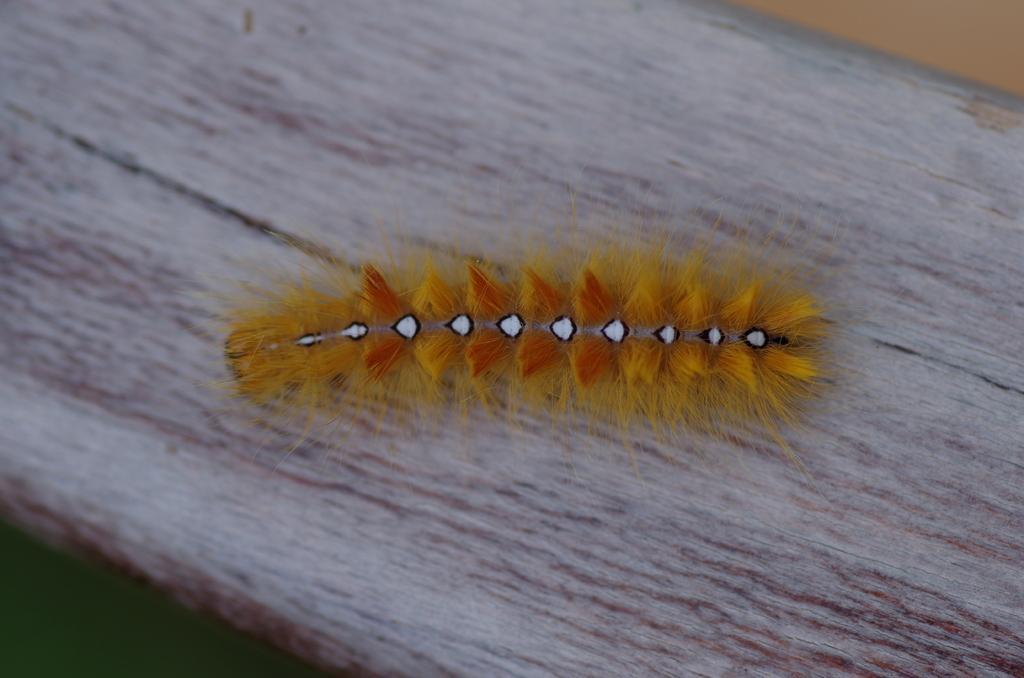What type of creature is in the image? There is an insect in the image. What is the insect sitting on? The insect is on a wooden surface. What type of pan is visible in the image? There is no pan present in the image; it only features an insect on a wooden surface. 